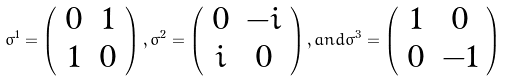Convert formula to latex. <formula><loc_0><loc_0><loc_500><loc_500>\sigma ^ { 1 } = \left ( \begin{array} { c c } 0 & 1 \\ 1 & 0 \end{array} \right ) , \sigma ^ { 2 } = \left ( \begin{array} { c c } 0 & - i \\ i & 0 \end{array} \right ) , a n d \sigma ^ { 3 } = \left ( \begin{array} { c c } 1 & 0 \\ 0 & - 1 \end{array} \right )</formula> 